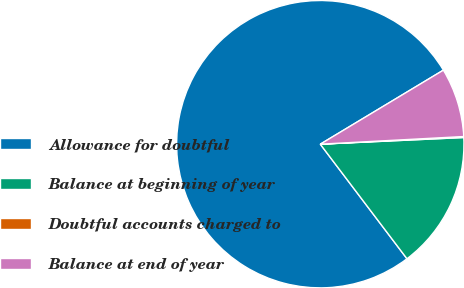Convert chart. <chart><loc_0><loc_0><loc_500><loc_500><pie_chart><fcel>Allowance for doubtful<fcel>Balance at beginning of year<fcel>Doubtful accounts charged to<fcel>Balance at end of year<nl><fcel>76.69%<fcel>15.43%<fcel>0.11%<fcel>7.77%<nl></chart> 